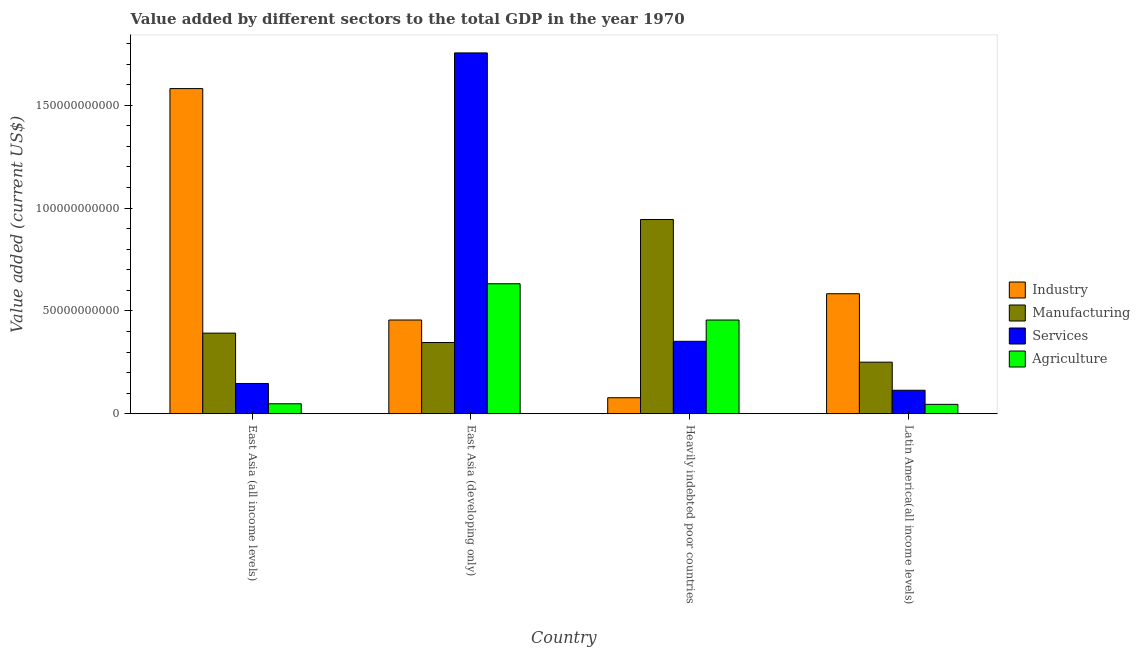Are the number of bars on each tick of the X-axis equal?
Provide a succinct answer. Yes. What is the label of the 1st group of bars from the left?
Offer a terse response. East Asia (all income levels). What is the value added by industrial sector in East Asia (all income levels)?
Offer a very short reply. 1.58e+11. Across all countries, what is the maximum value added by services sector?
Offer a terse response. 1.75e+11. Across all countries, what is the minimum value added by services sector?
Your response must be concise. 1.14e+1. In which country was the value added by industrial sector maximum?
Your answer should be compact. East Asia (all income levels). In which country was the value added by manufacturing sector minimum?
Give a very brief answer. Latin America(all income levels). What is the total value added by services sector in the graph?
Provide a succinct answer. 2.37e+11. What is the difference between the value added by services sector in Heavily indebted poor countries and that in Latin America(all income levels)?
Your answer should be compact. 2.38e+1. What is the difference between the value added by industrial sector in Latin America(all income levels) and the value added by manufacturing sector in Heavily indebted poor countries?
Offer a very short reply. -3.61e+1. What is the average value added by agricultural sector per country?
Your answer should be compact. 2.95e+1. What is the difference between the value added by agricultural sector and value added by industrial sector in Heavily indebted poor countries?
Ensure brevity in your answer.  3.78e+1. In how many countries, is the value added by manufacturing sector greater than 10000000000 US$?
Offer a very short reply. 4. What is the ratio of the value added by manufacturing sector in East Asia (all income levels) to that in Heavily indebted poor countries?
Provide a short and direct response. 0.41. Is the difference between the value added by manufacturing sector in East Asia (all income levels) and East Asia (developing only) greater than the difference between the value added by services sector in East Asia (all income levels) and East Asia (developing only)?
Provide a short and direct response. Yes. What is the difference between the highest and the second highest value added by industrial sector?
Your response must be concise. 9.98e+1. What is the difference between the highest and the lowest value added by industrial sector?
Ensure brevity in your answer.  1.50e+11. In how many countries, is the value added by manufacturing sector greater than the average value added by manufacturing sector taken over all countries?
Keep it short and to the point. 1. What does the 4th bar from the left in Heavily indebted poor countries represents?
Ensure brevity in your answer.  Agriculture. What does the 1st bar from the right in Latin America(all income levels) represents?
Your response must be concise. Agriculture. Is it the case that in every country, the sum of the value added by industrial sector and value added by manufacturing sector is greater than the value added by services sector?
Provide a short and direct response. No. Are the values on the major ticks of Y-axis written in scientific E-notation?
Offer a terse response. No. Does the graph contain any zero values?
Ensure brevity in your answer.  No. Where does the legend appear in the graph?
Keep it short and to the point. Center right. How are the legend labels stacked?
Ensure brevity in your answer.  Vertical. What is the title of the graph?
Provide a short and direct response. Value added by different sectors to the total GDP in the year 1970. Does "UNAIDS" appear as one of the legend labels in the graph?
Provide a short and direct response. No. What is the label or title of the Y-axis?
Provide a short and direct response. Value added (current US$). What is the Value added (current US$) of Industry in East Asia (all income levels)?
Offer a very short reply. 1.58e+11. What is the Value added (current US$) in Manufacturing in East Asia (all income levels)?
Provide a short and direct response. 3.92e+1. What is the Value added (current US$) in Services in East Asia (all income levels)?
Offer a terse response. 1.47e+1. What is the Value added (current US$) of Agriculture in East Asia (all income levels)?
Ensure brevity in your answer.  4.84e+09. What is the Value added (current US$) in Industry in East Asia (developing only)?
Keep it short and to the point. 4.56e+1. What is the Value added (current US$) in Manufacturing in East Asia (developing only)?
Provide a succinct answer. 3.46e+1. What is the Value added (current US$) of Services in East Asia (developing only)?
Your answer should be very brief. 1.75e+11. What is the Value added (current US$) in Agriculture in East Asia (developing only)?
Your answer should be very brief. 6.32e+1. What is the Value added (current US$) in Industry in Heavily indebted poor countries?
Offer a very short reply. 7.78e+09. What is the Value added (current US$) of Manufacturing in Heavily indebted poor countries?
Give a very brief answer. 9.45e+1. What is the Value added (current US$) in Services in Heavily indebted poor countries?
Your response must be concise. 3.52e+1. What is the Value added (current US$) in Agriculture in Heavily indebted poor countries?
Offer a terse response. 4.56e+1. What is the Value added (current US$) of Industry in Latin America(all income levels)?
Offer a very short reply. 5.84e+1. What is the Value added (current US$) of Manufacturing in Latin America(all income levels)?
Your answer should be compact. 2.51e+1. What is the Value added (current US$) of Services in Latin America(all income levels)?
Provide a short and direct response. 1.14e+1. What is the Value added (current US$) in Agriculture in Latin America(all income levels)?
Ensure brevity in your answer.  4.56e+09. Across all countries, what is the maximum Value added (current US$) in Industry?
Offer a terse response. 1.58e+11. Across all countries, what is the maximum Value added (current US$) in Manufacturing?
Your answer should be very brief. 9.45e+1. Across all countries, what is the maximum Value added (current US$) in Services?
Your answer should be very brief. 1.75e+11. Across all countries, what is the maximum Value added (current US$) of Agriculture?
Keep it short and to the point. 6.32e+1. Across all countries, what is the minimum Value added (current US$) of Industry?
Your response must be concise. 7.78e+09. Across all countries, what is the minimum Value added (current US$) of Manufacturing?
Provide a succinct answer. 2.51e+1. Across all countries, what is the minimum Value added (current US$) of Services?
Ensure brevity in your answer.  1.14e+1. Across all countries, what is the minimum Value added (current US$) in Agriculture?
Ensure brevity in your answer.  4.56e+09. What is the total Value added (current US$) in Industry in the graph?
Give a very brief answer. 2.70e+11. What is the total Value added (current US$) of Manufacturing in the graph?
Make the answer very short. 1.93e+11. What is the total Value added (current US$) of Services in the graph?
Offer a very short reply. 2.37e+11. What is the total Value added (current US$) of Agriculture in the graph?
Keep it short and to the point. 1.18e+11. What is the difference between the Value added (current US$) of Industry in East Asia (all income levels) and that in East Asia (developing only)?
Ensure brevity in your answer.  1.13e+11. What is the difference between the Value added (current US$) in Manufacturing in East Asia (all income levels) and that in East Asia (developing only)?
Make the answer very short. 4.57e+09. What is the difference between the Value added (current US$) in Services in East Asia (all income levels) and that in East Asia (developing only)?
Offer a very short reply. -1.61e+11. What is the difference between the Value added (current US$) in Agriculture in East Asia (all income levels) and that in East Asia (developing only)?
Provide a succinct answer. -5.84e+1. What is the difference between the Value added (current US$) of Industry in East Asia (all income levels) and that in Heavily indebted poor countries?
Your response must be concise. 1.50e+11. What is the difference between the Value added (current US$) of Manufacturing in East Asia (all income levels) and that in Heavily indebted poor countries?
Your response must be concise. -5.53e+1. What is the difference between the Value added (current US$) of Services in East Asia (all income levels) and that in Heavily indebted poor countries?
Give a very brief answer. -2.05e+1. What is the difference between the Value added (current US$) of Agriculture in East Asia (all income levels) and that in Heavily indebted poor countries?
Make the answer very short. -4.07e+1. What is the difference between the Value added (current US$) of Industry in East Asia (all income levels) and that in Latin America(all income levels)?
Your answer should be compact. 9.98e+1. What is the difference between the Value added (current US$) in Manufacturing in East Asia (all income levels) and that in Latin America(all income levels)?
Give a very brief answer. 1.41e+1. What is the difference between the Value added (current US$) in Services in East Asia (all income levels) and that in Latin America(all income levels)?
Your answer should be compact. 3.30e+09. What is the difference between the Value added (current US$) in Agriculture in East Asia (all income levels) and that in Latin America(all income levels)?
Offer a terse response. 2.79e+08. What is the difference between the Value added (current US$) of Industry in East Asia (developing only) and that in Heavily indebted poor countries?
Provide a succinct answer. 3.78e+1. What is the difference between the Value added (current US$) of Manufacturing in East Asia (developing only) and that in Heavily indebted poor countries?
Your response must be concise. -5.98e+1. What is the difference between the Value added (current US$) in Services in East Asia (developing only) and that in Heavily indebted poor countries?
Make the answer very short. 1.40e+11. What is the difference between the Value added (current US$) of Agriculture in East Asia (developing only) and that in Heavily indebted poor countries?
Keep it short and to the point. 1.76e+1. What is the difference between the Value added (current US$) in Industry in East Asia (developing only) and that in Latin America(all income levels)?
Provide a succinct answer. -1.28e+1. What is the difference between the Value added (current US$) in Manufacturing in East Asia (developing only) and that in Latin America(all income levels)?
Offer a very short reply. 9.55e+09. What is the difference between the Value added (current US$) in Services in East Asia (developing only) and that in Latin America(all income levels)?
Your response must be concise. 1.64e+11. What is the difference between the Value added (current US$) in Agriculture in East Asia (developing only) and that in Latin America(all income levels)?
Keep it short and to the point. 5.86e+1. What is the difference between the Value added (current US$) in Industry in Heavily indebted poor countries and that in Latin America(all income levels)?
Your response must be concise. -5.06e+1. What is the difference between the Value added (current US$) in Manufacturing in Heavily indebted poor countries and that in Latin America(all income levels)?
Offer a very short reply. 6.94e+1. What is the difference between the Value added (current US$) in Services in Heavily indebted poor countries and that in Latin America(all income levels)?
Your response must be concise. 2.38e+1. What is the difference between the Value added (current US$) of Agriculture in Heavily indebted poor countries and that in Latin America(all income levels)?
Make the answer very short. 4.10e+1. What is the difference between the Value added (current US$) of Industry in East Asia (all income levels) and the Value added (current US$) of Manufacturing in East Asia (developing only)?
Offer a terse response. 1.23e+11. What is the difference between the Value added (current US$) of Industry in East Asia (all income levels) and the Value added (current US$) of Services in East Asia (developing only)?
Your answer should be compact. -1.73e+1. What is the difference between the Value added (current US$) in Industry in East Asia (all income levels) and the Value added (current US$) in Agriculture in East Asia (developing only)?
Your answer should be compact. 9.49e+1. What is the difference between the Value added (current US$) of Manufacturing in East Asia (all income levels) and the Value added (current US$) of Services in East Asia (developing only)?
Make the answer very short. -1.36e+11. What is the difference between the Value added (current US$) in Manufacturing in East Asia (all income levels) and the Value added (current US$) in Agriculture in East Asia (developing only)?
Your answer should be very brief. -2.40e+1. What is the difference between the Value added (current US$) of Services in East Asia (all income levels) and the Value added (current US$) of Agriculture in East Asia (developing only)?
Offer a terse response. -4.85e+1. What is the difference between the Value added (current US$) in Industry in East Asia (all income levels) and the Value added (current US$) in Manufacturing in Heavily indebted poor countries?
Provide a short and direct response. 6.37e+1. What is the difference between the Value added (current US$) in Industry in East Asia (all income levels) and the Value added (current US$) in Services in Heavily indebted poor countries?
Make the answer very short. 1.23e+11. What is the difference between the Value added (current US$) in Industry in East Asia (all income levels) and the Value added (current US$) in Agriculture in Heavily indebted poor countries?
Offer a very short reply. 1.13e+11. What is the difference between the Value added (current US$) in Manufacturing in East Asia (all income levels) and the Value added (current US$) in Services in Heavily indebted poor countries?
Offer a very short reply. 3.97e+09. What is the difference between the Value added (current US$) of Manufacturing in East Asia (all income levels) and the Value added (current US$) of Agriculture in Heavily indebted poor countries?
Provide a short and direct response. -6.38e+09. What is the difference between the Value added (current US$) of Services in East Asia (all income levels) and the Value added (current US$) of Agriculture in Heavily indebted poor countries?
Your answer should be compact. -3.09e+1. What is the difference between the Value added (current US$) in Industry in East Asia (all income levels) and the Value added (current US$) in Manufacturing in Latin America(all income levels)?
Give a very brief answer. 1.33e+11. What is the difference between the Value added (current US$) in Industry in East Asia (all income levels) and the Value added (current US$) in Services in Latin America(all income levels)?
Your response must be concise. 1.47e+11. What is the difference between the Value added (current US$) in Industry in East Asia (all income levels) and the Value added (current US$) in Agriculture in Latin America(all income levels)?
Your answer should be compact. 1.54e+11. What is the difference between the Value added (current US$) of Manufacturing in East Asia (all income levels) and the Value added (current US$) of Services in Latin America(all income levels)?
Provide a succinct answer. 2.78e+1. What is the difference between the Value added (current US$) in Manufacturing in East Asia (all income levels) and the Value added (current US$) in Agriculture in Latin America(all income levels)?
Provide a short and direct response. 3.46e+1. What is the difference between the Value added (current US$) in Services in East Asia (all income levels) and the Value added (current US$) in Agriculture in Latin America(all income levels)?
Your response must be concise. 1.02e+1. What is the difference between the Value added (current US$) in Industry in East Asia (developing only) and the Value added (current US$) in Manufacturing in Heavily indebted poor countries?
Offer a terse response. -4.89e+1. What is the difference between the Value added (current US$) of Industry in East Asia (developing only) and the Value added (current US$) of Services in Heavily indebted poor countries?
Your answer should be very brief. 1.04e+1. What is the difference between the Value added (current US$) of Industry in East Asia (developing only) and the Value added (current US$) of Agriculture in Heavily indebted poor countries?
Provide a short and direct response. 2.12e+06. What is the difference between the Value added (current US$) of Manufacturing in East Asia (developing only) and the Value added (current US$) of Services in Heavily indebted poor countries?
Keep it short and to the point. -5.91e+08. What is the difference between the Value added (current US$) of Manufacturing in East Asia (developing only) and the Value added (current US$) of Agriculture in Heavily indebted poor countries?
Ensure brevity in your answer.  -1.09e+1. What is the difference between the Value added (current US$) of Services in East Asia (developing only) and the Value added (current US$) of Agriculture in Heavily indebted poor countries?
Offer a very short reply. 1.30e+11. What is the difference between the Value added (current US$) in Industry in East Asia (developing only) and the Value added (current US$) in Manufacturing in Latin America(all income levels)?
Your response must be concise. 2.05e+1. What is the difference between the Value added (current US$) of Industry in East Asia (developing only) and the Value added (current US$) of Services in Latin America(all income levels)?
Provide a succinct answer. 3.42e+1. What is the difference between the Value added (current US$) in Industry in East Asia (developing only) and the Value added (current US$) in Agriculture in Latin America(all income levels)?
Offer a very short reply. 4.10e+1. What is the difference between the Value added (current US$) of Manufacturing in East Asia (developing only) and the Value added (current US$) of Services in Latin America(all income levels)?
Your answer should be very brief. 2.32e+1. What is the difference between the Value added (current US$) of Manufacturing in East Asia (developing only) and the Value added (current US$) of Agriculture in Latin America(all income levels)?
Make the answer very short. 3.01e+1. What is the difference between the Value added (current US$) of Services in East Asia (developing only) and the Value added (current US$) of Agriculture in Latin America(all income levels)?
Make the answer very short. 1.71e+11. What is the difference between the Value added (current US$) of Industry in Heavily indebted poor countries and the Value added (current US$) of Manufacturing in Latin America(all income levels)?
Make the answer very short. -1.73e+1. What is the difference between the Value added (current US$) in Industry in Heavily indebted poor countries and the Value added (current US$) in Services in Latin America(all income levels)?
Make the answer very short. -3.63e+09. What is the difference between the Value added (current US$) of Industry in Heavily indebted poor countries and the Value added (current US$) of Agriculture in Latin America(all income levels)?
Keep it short and to the point. 3.22e+09. What is the difference between the Value added (current US$) in Manufacturing in Heavily indebted poor countries and the Value added (current US$) in Services in Latin America(all income levels)?
Your answer should be compact. 8.30e+1. What is the difference between the Value added (current US$) in Manufacturing in Heavily indebted poor countries and the Value added (current US$) in Agriculture in Latin America(all income levels)?
Your answer should be compact. 8.99e+1. What is the difference between the Value added (current US$) of Services in Heavily indebted poor countries and the Value added (current US$) of Agriculture in Latin America(all income levels)?
Keep it short and to the point. 3.07e+1. What is the average Value added (current US$) in Industry per country?
Ensure brevity in your answer.  6.75e+1. What is the average Value added (current US$) in Manufacturing per country?
Ensure brevity in your answer.  4.83e+1. What is the average Value added (current US$) of Services per country?
Give a very brief answer. 5.92e+1. What is the average Value added (current US$) in Agriculture per country?
Keep it short and to the point. 2.95e+1. What is the difference between the Value added (current US$) of Industry and Value added (current US$) of Manufacturing in East Asia (all income levels)?
Offer a very short reply. 1.19e+11. What is the difference between the Value added (current US$) in Industry and Value added (current US$) in Services in East Asia (all income levels)?
Your response must be concise. 1.43e+11. What is the difference between the Value added (current US$) of Industry and Value added (current US$) of Agriculture in East Asia (all income levels)?
Your response must be concise. 1.53e+11. What is the difference between the Value added (current US$) in Manufacturing and Value added (current US$) in Services in East Asia (all income levels)?
Give a very brief answer. 2.45e+1. What is the difference between the Value added (current US$) in Manufacturing and Value added (current US$) in Agriculture in East Asia (all income levels)?
Keep it short and to the point. 3.44e+1. What is the difference between the Value added (current US$) in Services and Value added (current US$) in Agriculture in East Asia (all income levels)?
Make the answer very short. 9.88e+09. What is the difference between the Value added (current US$) in Industry and Value added (current US$) in Manufacturing in East Asia (developing only)?
Ensure brevity in your answer.  1.09e+1. What is the difference between the Value added (current US$) in Industry and Value added (current US$) in Services in East Asia (developing only)?
Provide a succinct answer. -1.30e+11. What is the difference between the Value added (current US$) of Industry and Value added (current US$) of Agriculture in East Asia (developing only)?
Make the answer very short. -1.76e+1. What is the difference between the Value added (current US$) in Manufacturing and Value added (current US$) in Services in East Asia (developing only)?
Your answer should be very brief. -1.41e+11. What is the difference between the Value added (current US$) of Manufacturing and Value added (current US$) of Agriculture in East Asia (developing only)?
Offer a terse response. -2.86e+1. What is the difference between the Value added (current US$) of Services and Value added (current US$) of Agriculture in East Asia (developing only)?
Make the answer very short. 1.12e+11. What is the difference between the Value added (current US$) of Industry and Value added (current US$) of Manufacturing in Heavily indebted poor countries?
Make the answer very short. -8.67e+1. What is the difference between the Value added (current US$) in Industry and Value added (current US$) in Services in Heavily indebted poor countries?
Your answer should be very brief. -2.74e+1. What is the difference between the Value added (current US$) of Industry and Value added (current US$) of Agriculture in Heavily indebted poor countries?
Your answer should be very brief. -3.78e+1. What is the difference between the Value added (current US$) in Manufacturing and Value added (current US$) in Services in Heavily indebted poor countries?
Make the answer very short. 5.92e+1. What is the difference between the Value added (current US$) of Manufacturing and Value added (current US$) of Agriculture in Heavily indebted poor countries?
Provide a short and direct response. 4.89e+1. What is the difference between the Value added (current US$) in Services and Value added (current US$) in Agriculture in Heavily indebted poor countries?
Give a very brief answer. -1.04e+1. What is the difference between the Value added (current US$) in Industry and Value added (current US$) in Manufacturing in Latin America(all income levels)?
Offer a very short reply. 3.33e+1. What is the difference between the Value added (current US$) in Industry and Value added (current US$) in Services in Latin America(all income levels)?
Keep it short and to the point. 4.69e+1. What is the difference between the Value added (current US$) in Industry and Value added (current US$) in Agriculture in Latin America(all income levels)?
Your answer should be very brief. 5.38e+1. What is the difference between the Value added (current US$) of Manufacturing and Value added (current US$) of Services in Latin America(all income levels)?
Ensure brevity in your answer.  1.37e+1. What is the difference between the Value added (current US$) of Manufacturing and Value added (current US$) of Agriculture in Latin America(all income levels)?
Offer a very short reply. 2.05e+1. What is the difference between the Value added (current US$) in Services and Value added (current US$) in Agriculture in Latin America(all income levels)?
Offer a very short reply. 6.85e+09. What is the ratio of the Value added (current US$) in Industry in East Asia (all income levels) to that in East Asia (developing only)?
Provide a succinct answer. 3.47. What is the ratio of the Value added (current US$) in Manufacturing in East Asia (all income levels) to that in East Asia (developing only)?
Keep it short and to the point. 1.13. What is the ratio of the Value added (current US$) in Services in East Asia (all income levels) to that in East Asia (developing only)?
Offer a very short reply. 0.08. What is the ratio of the Value added (current US$) in Agriculture in East Asia (all income levels) to that in East Asia (developing only)?
Your response must be concise. 0.08. What is the ratio of the Value added (current US$) of Industry in East Asia (all income levels) to that in Heavily indebted poor countries?
Give a very brief answer. 20.31. What is the ratio of the Value added (current US$) of Manufacturing in East Asia (all income levels) to that in Heavily indebted poor countries?
Provide a succinct answer. 0.41. What is the ratio of the Value added (current US$) of Services in East Asia (all income levels) to that in Heavily indebted poor countries?
Offer a terse response. 0.42. What is the ratio of the Value added (current US$) in Agriculture in East Asia (all income levels) to that in Heavily indebted poor countries?
Give a very brief answer. 0.11. What is the ratio of the Value added (current US$) of Industry in East Asia (all income levels) to that in Latin America(all income levels)?
Your answer should be very brief. 2.71. What is the ratio of the Value added (current US$) of Manufacturing in East Asia (all income levels) to that in Latin America(all income levels)?
Provide a short and direct response. 1.56. What is the ratio of the Value added (current US$) of Services in East Asia (all income levels) to that in Latin America(all income levels)?
Your response must be concise. 1.29. What is the ratio of the Value added (current US$) in Agriculture in East Asia (all income levels) to that in Latin America(all income levels)?
Provide a short and direct response. 1.06. What is the ratio of the Value added (current US$) in Industry in East Asia (developing only) to that in Heavily indebted poor countries?
Your answer should be compact. 5.85. What is the ratio of the Value added (current US$) of Manufacturing in East Asia (developing only) to that in Heavily indebted poor countries?
Provide a succinct answer. 0.37. What is the ratio of the Value added (current US$) of Services in East Asia (developing only) to that in Heavily indebted poor countries?
Provide a succinct answer. 4.98. What is the ratio of the Value added (current US$) in Agriculture in East Asia (developing only) to that in Heavily indebted poor countries?
Make the answer very short. 1.39. What is the ratio of the Value added (current US$) of Industry in East Asia (developing only) to that in Latin America(all income levels)?
Make the answer very short. 0.78. What is the ratio of the Value added (current US$) in Manufacturing in East Asia (developing only) to that in Latin America(all income levels)?
Give a very brief answer. 1.38. What is the ratio of the Value added (current US$) of Services in East Asia (developing only) to that in Latin America(all income levels)?
Give a very brief answer. 15.37. What is the ratio of the Value added (current US$) in Agriculture in East Asia (developing only) to that in Latin America(all income levels)?
Offer a terse response. 13.85. What is the ratio of the Value added (current US$) in Industry in Heavily indebted poor countries to that in Latin America(all income levels)?
Offer a very short reply. 0.13. What is the ratio of the Value added (current US$) in Manufacturing in Heavily indebted poor countries to that in Latin America(all income levels)?
Provide a succinct answer. 3.77. What is the ratio of the Value added (current US$) in Services in Heavily indebted poor countries to that in Latin America(all income levels)?
Keep it short and to the point. 3.09. What is the ratio of the Value added (current US$) of Agriculture in Heavily indebted poor countries to that in Latin America(all income levels)?
Provide a succinct answer. 9.99. What is the difference between the highest and the second highest Value added (current US$) of Industry?
Your answer should be very brief. 9.98e+1. What is the difference between the highest and the second highest Value added (current US$) of Manufacturing?
Offer a terse response. 5.53e+1. What is the difference between the highest and the second highest Value added (current US$) in Services?
Provide a short and direct response. 1.40e+11. What is the difference between the highest and the second highest Value added (current US$) in Agriculture?
Ensure brevity in your answer.  1.76e+1. What is the difference between the highest and the lowest Value added (current US$) of Industry?
Your response must be concise. 1.50e+11. What is the difference between the highest and the lowest Value added (current US$) of Manufacturing?
Give a very brief answer. 6.94e+1. What is the difference between the highest and the lowest Value added (current US$) in Services?
Provide a succinct answer. 1.64e+11. What is the difference between the highest and the lowest Value added (current US$) in Agriculture?
Offer a terse response. 5.86e+1. 